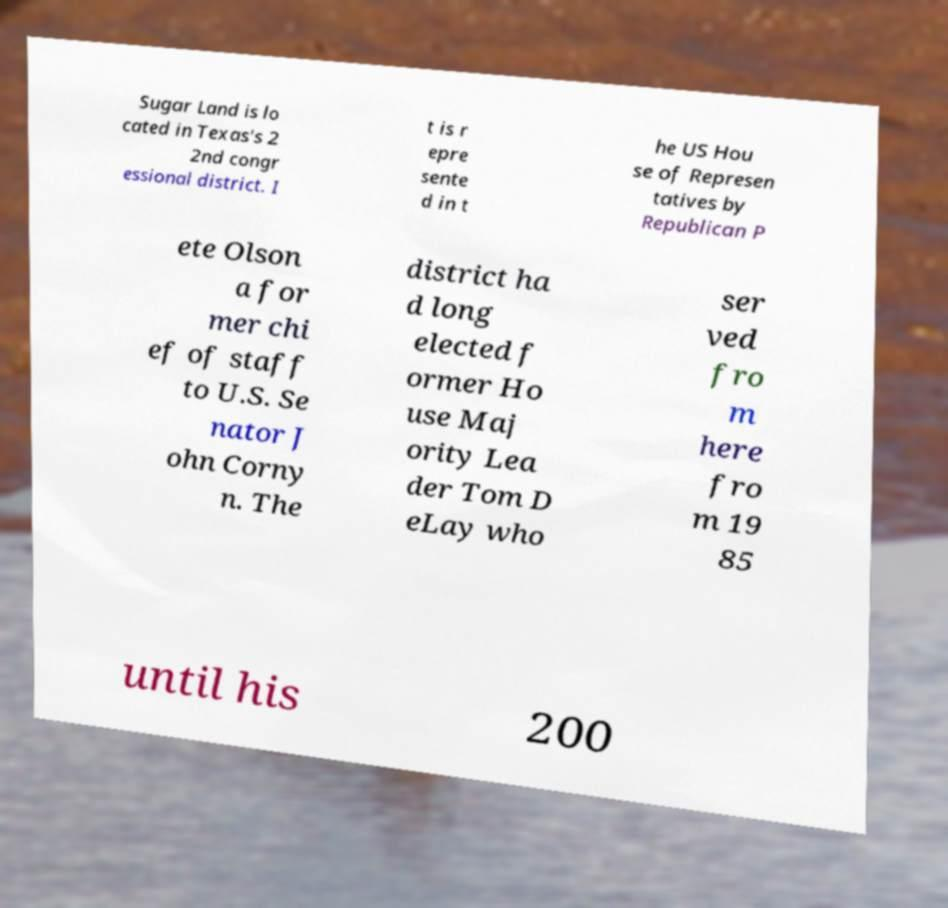Can you accurately transcribe the text from the provided image for me? Sugar Land is lo cated in Texas's 2 2nd congr essional district. I t is r epre sente d in t he US Hou se of Represen tatives by Republican P ete Olson a for mer chi ef of staff to U.S. Se nator J ohn Corny n. The district ha d long elected f ormer Ho use Maj ority Lea der Tom D eLay who ser ved fro m here fro m 19 85 until his 200 